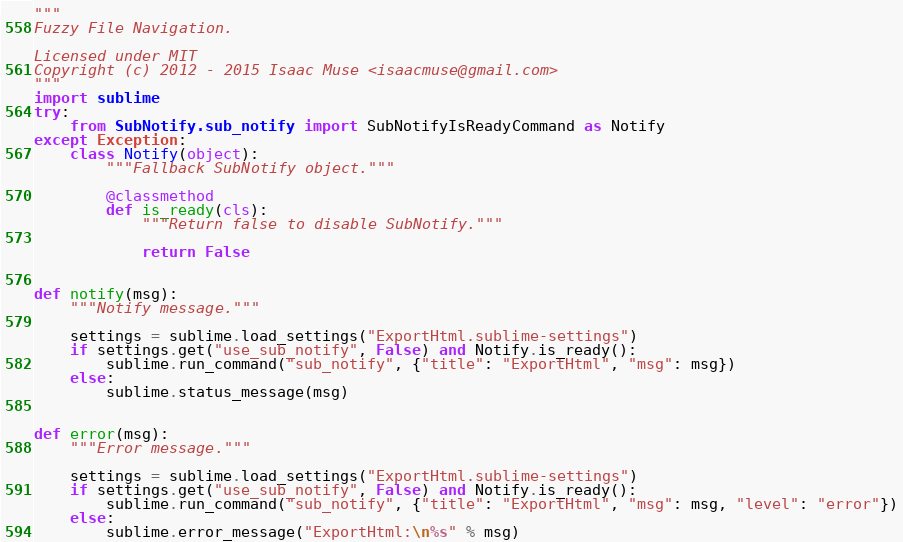Convert code to text. <code><loc_0><loc_0><loc_500><loc_500><_Python_>"""
Fuzzy File Navigation.

Licensed under MIT
Copyright (c) 2012 - 2015 Isaac Muse <isaacmuse@gmail.com>
"""
import sublime
try:
    from SubNotify.sub_notify import SubNotifyIsReadyCommand as Notify
except Exception:
    class Notify(object):
        """Fallback SubNotify object."""

        @classmethod
        def is_ready(cls):
            """Return false to disable SubNotify."""

            return False


def notify(msg):
    """Notify message."""

    settings = sublime.load_settings("ExportHtml.sublime-settings")
    if settings.get("use_sub_notify", False) and Notify.is_ready():
        sublime.run_command("sub_notify", {"title": "ExportHtml", "msg": msg})
    else:
        sublime.status_message(msg)


def error(msg):
    """Error message."""

    settings = sublime.load_settings("ExportHtml.sublime-settings")
    if settings.get("use_sub_notify", False) and Notify.is_ready():
        sublime.run_command("sub_notify", {"title": "ExportHtml", "msg": msg, "level": "error"})
    else:
        sublime.error_message("ExportHtml:\n%s" % msg)
</code> 